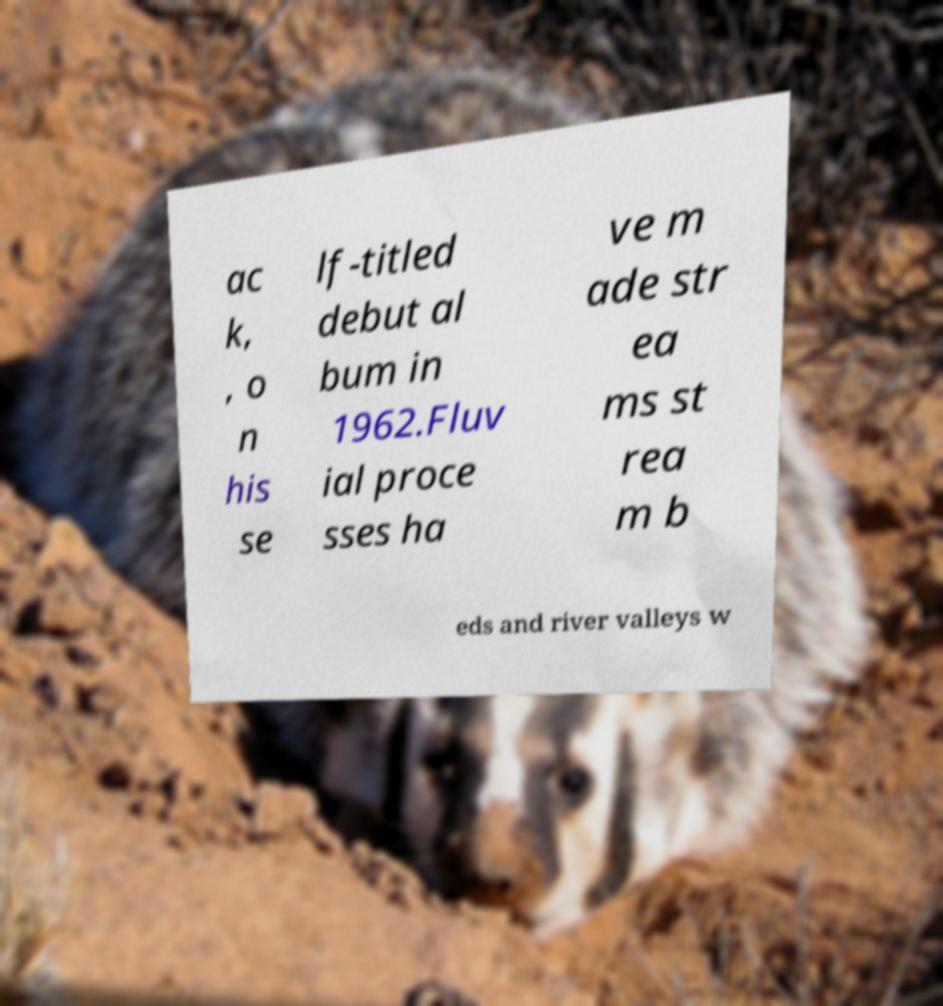I need the written content from this picture converted into text. Can you do that? ac k, , o n his se lf-titled debut al bum in 1962.Fluv ial proce sses ha ve m ade str ea ms st rea m b eds and river valleys w 